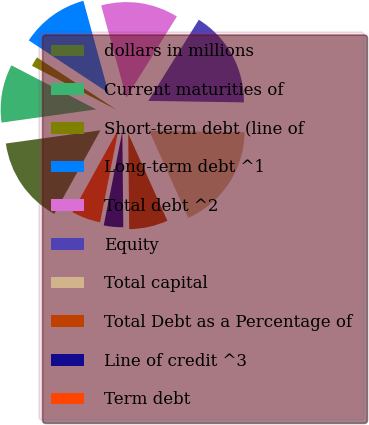Convert chart to OTSL. <chart><loc_0><loc_0><loc_500><loc_500><pie_chart><fcel>dollars in millions<fcel>Current maturities of<fcel>Short-term debt (line of<fcel>Long-term debt ^1<fcel>Total debt ^2<fcel>Equity<fcel>Total capital<fcel>Total Debt as a Percentage of<fcel>Line of credit ^3<fcel>Term debt<nl><fcel>14.75%<fcel>9.84%<fcel>1.64%<fcel>11.48%<fcel>13.11%<fcel>16.39%<fcel>18.03%<fcel>6.56%<fcel>3.28%<fcel>4.92%<nl></chart> 